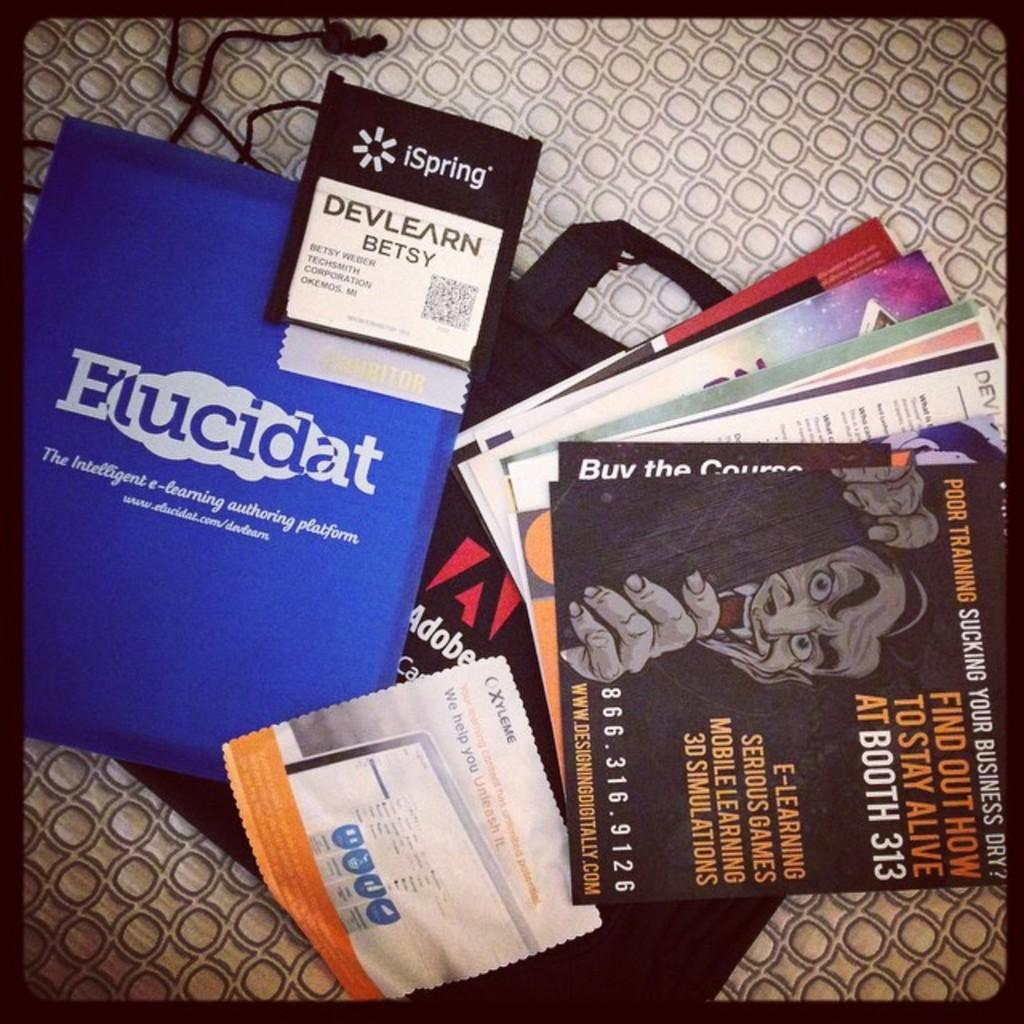<image>
Write a terse but informative summary of the picture. Several printed materials laying on a surface, one with a title of Elucidat. 